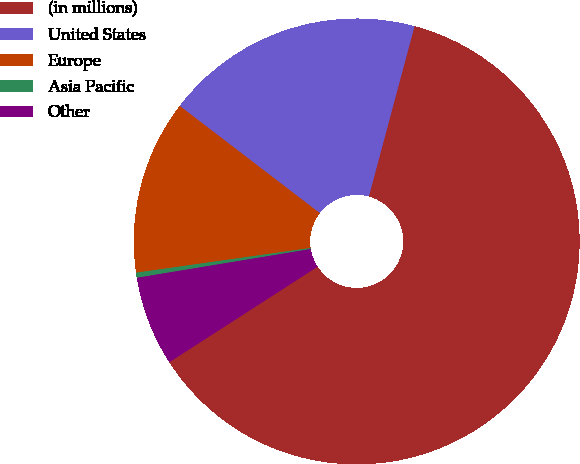<chart> <loc_0><loc_0><loc_500><loc_500><pie_chart><fcel>(in millions)<fcel>United States<fcel>Europe<fcel>Asia Pacific<fcel>Other<nl><fcel>61.72%<fcel>18.77%<fcel>12.64%<fcel>0.37%<fcel>6.5%<nl></chart> 